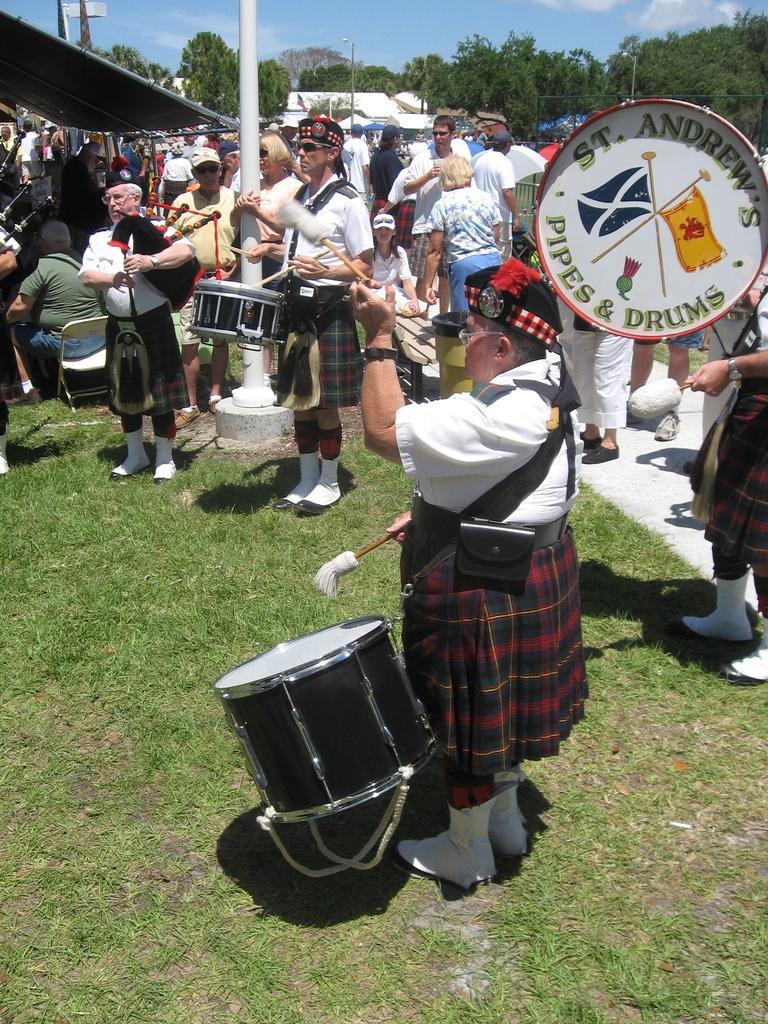Please provide a concise description of this image. In this image I can see number of persons are standing on the ground holding few musical instruments. I can see few people sitting, some grass, few poles, few buildings and few trees. In the background I can see the sky. 